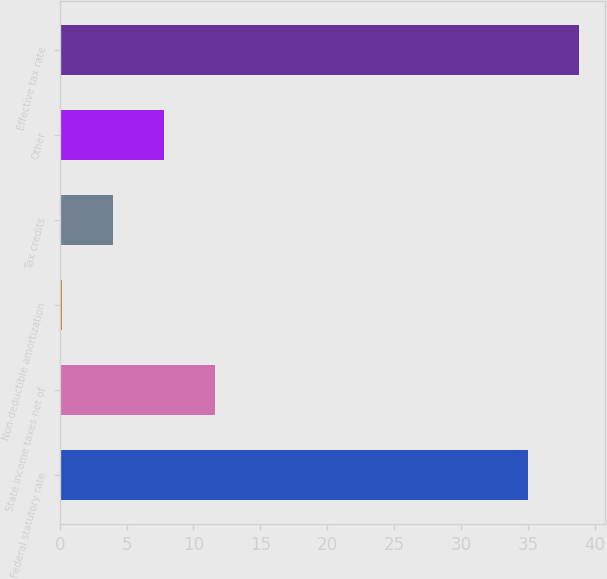Convert chart. <chart><loc_0><loc_0><loc_500><loc_500><bar_chart><fcel>Federal statutory rate<fcel>State income taxes net of<fcel>Non-deductible amortization<fcel>Tax credits<fcel>Other<fcel>Effective tax rate<nl><fcel>35<fcel>11.6<fcel>0.2<fcel>4<fcel>7.8<fcel>38.8<nl></chart> 